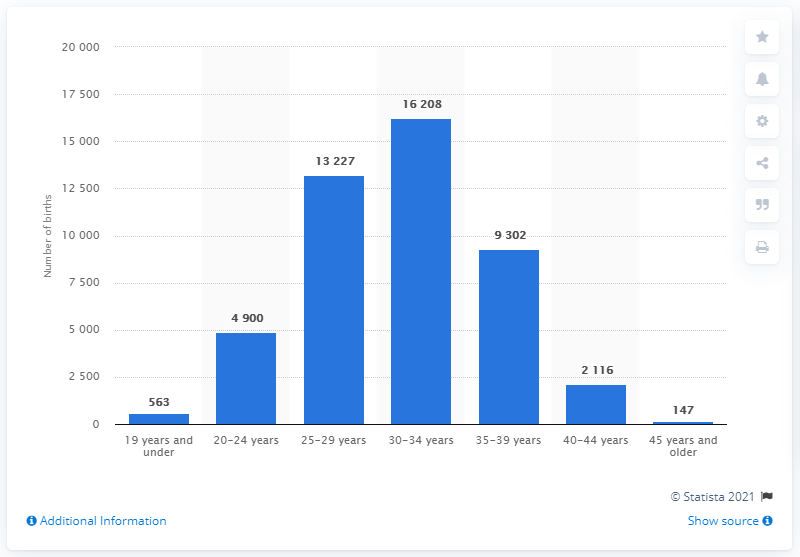Identify some key points in this picture. There were 147 children born in Finland in the age group of 45 years and older in the year mentioned. In 2020, a total of 16,208 children were born to women aged 30 to 34 in Finland. 